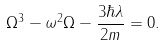<formula> <loc_0><loc_0><loc_500><loc_500>\Omega ^ { 3 } - \omega ^ { 2 } \Omega - \frac { 3 \hbar { \lambda } } { 2 m } = 0 .</formula> 